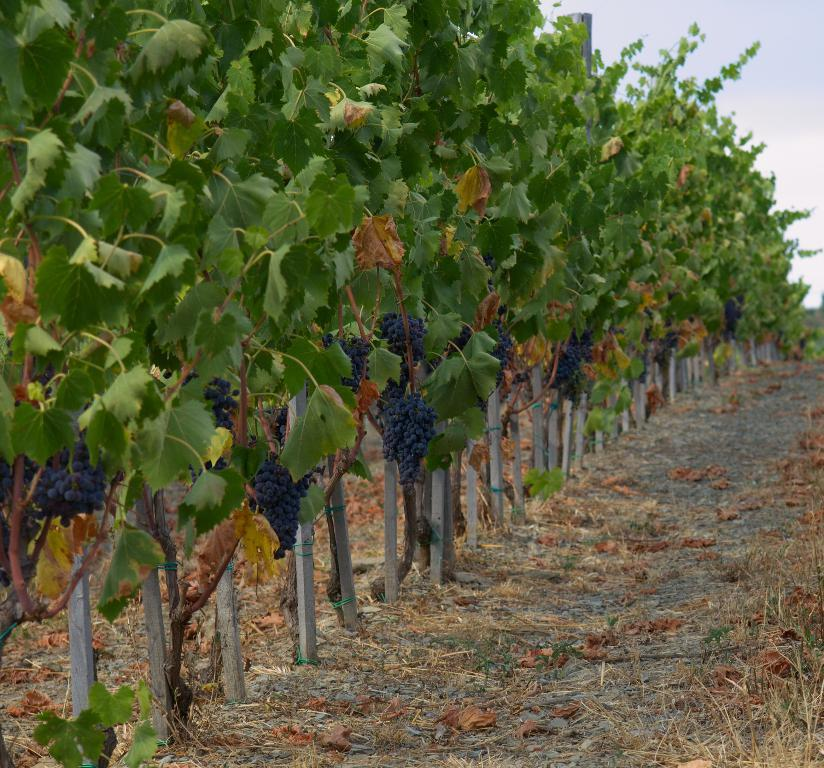Where was the picture taken? The picture was clicked outside. What can be seen hanging on the trees in the image? There are bunches of grapes hanging on the trees. What structures are visible in the image? There are poles visible in the image. What is the condition of the ground in the image? Dry leaves are present, indicating that the ground is dry. What is visible in the background of the image? There is a sky visible in the background. What type of shoes can be seen on the grapes in the image? There are no shoes present in the image, as the subject is grapes hanging on trees. 